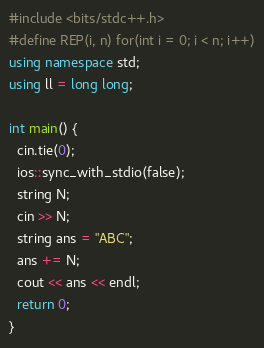<code> <loc_0><loc_0><loc_500><loc_500><_C++_>#include <bits/stdc++.h>
#define REP(i, n) for(int i = 0; i < n; i++)
using namespace std;
using ll = long long;

int main() {
  cin.tie(0);
  ios::sync_with_stdio(false);
  string N;
  cin >> N;
  string ans = "ABC";
  ans += N;
  cout << ans << endl;
  return 0;
}</code> 